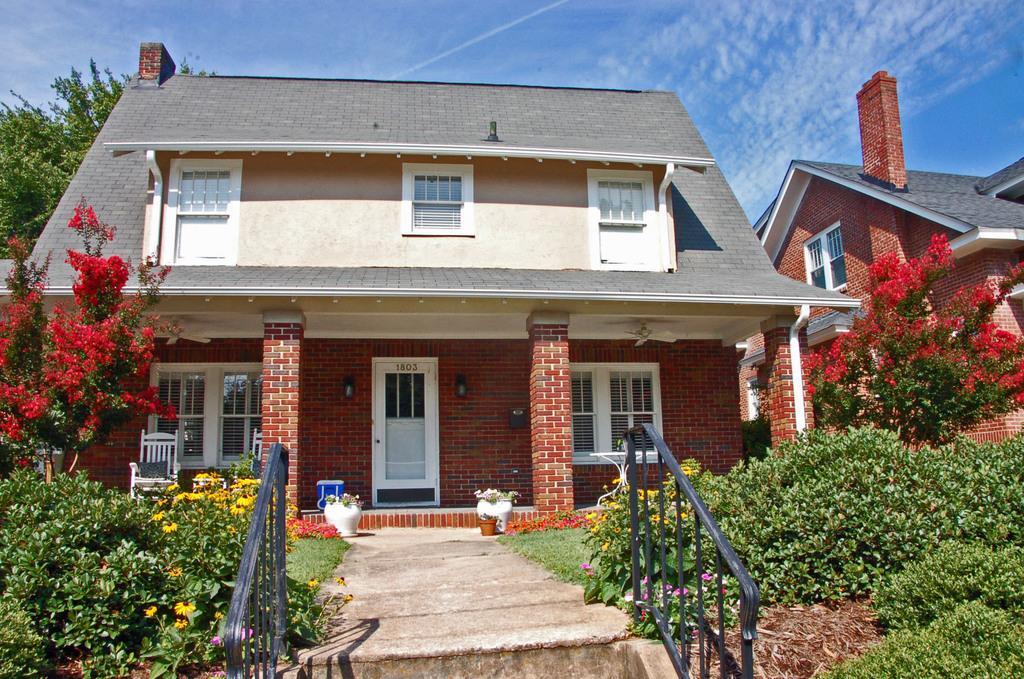Could you give a brief overview of what you see in this image? In the picture I can see buildings, trees, flower plants, pillars, a chair, fence and some other objects on the ground. In the background I can see the sky. 